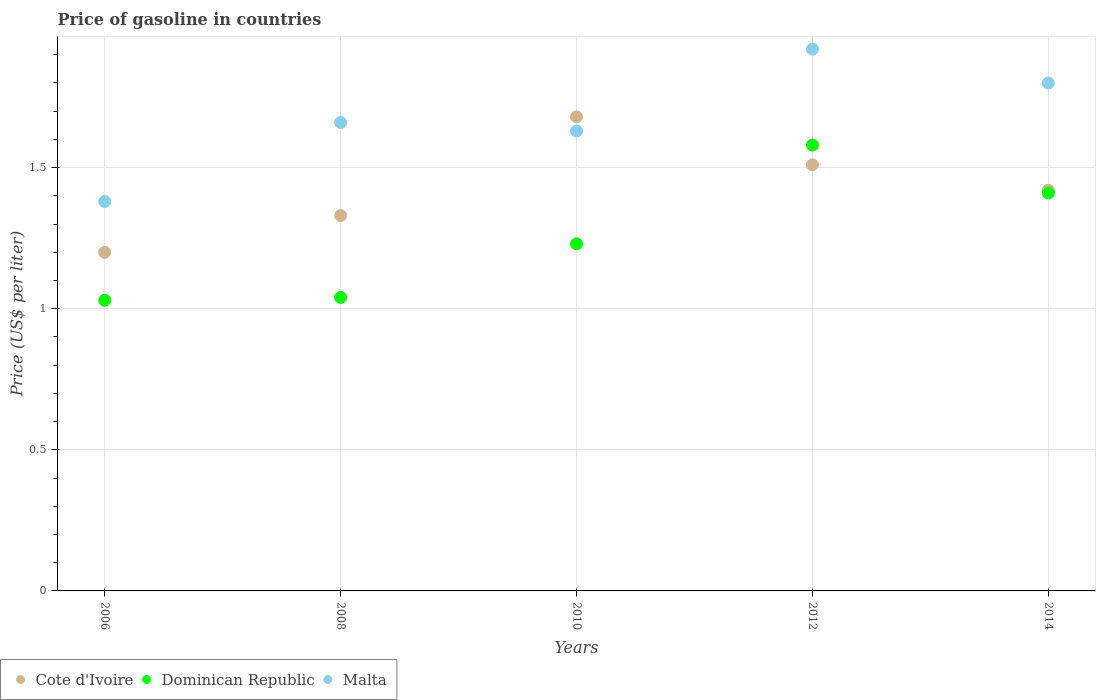Is the number of dotlines equal to the number of legend labels?
Your answer should be compact. Yes. What is the price of gasoline in Cote d'Ivoire in 2012?
Offer a terse response. 1.51. Across all years, what is the maximum price of gasoline in Dominican Republic?
Give a very brief answer. 1.58. Across all years, what is the minimum price of gasoline in Dominican Republic?
Keep it short and to the point. 1.03. In which year was the price of gasoline in Cote d'Ivoire maximum?
Keep it short and to the point. 2010. What is the total price of gasoline in Dominican Republic in the graph?
Ensure brevity in your answer.  6.29. What is the difference between the price of gasoline in Cote d'Ivoire in 2008 and that in 2014?
Ensure brevity in your answer.  -0.09. What is the difference between the price of gasoline in Dominican Republic in 2014 and the price of gasoline in Cote d'Ivoire in 2012?
Provide a succinct answer. -0.1. What is the average price of gasoline in Cote d'Ivoire per year?
Your answer should be compact. 1.43. In the year 2008, what is the difference between the price of gasoline in Cote d'Ivoire and price of gasoline in Dominican Republic?
Ensure brevity in your answer.  0.29. In how many years, is the price of gasoline in Malta greater than 0.8 US$?
Your response must be concise. 5. What is the ratio of the price of gasoline in Malta in 2008 to that in 2012?
Your answer should be compact. 0.86. Is the difference between the price of gasoline in Cote d'Ivoire in 2010 and 2012 greater than the difference between the price of gasoline in Dominican Republic in 2010 and 2012?
Keep it short and to the point. Yes. What is the difference between the highest and the second highest price of gasoline in Cote d'Ivoire?
Offer a terse response. 0.17. What is the difference between the highest and the lowest price of gasoline in Malta?
Your response must be concise. 0.54. Is the sum of the price of gasoline in Dominican Republic in 2008 and 2012 greater than the maximum price of gasoline in Malta across all years?
Give a very brief answer. Yes. Is it the case that in every year, the sum of the price of gasoline in Cote d'Ivoire and price of gasoline in Dominican Republic  is greater than the price of gasoline in Malta?
Your answer should be compact. Yes. Is the price of gasoline in Dominican Republic strictly greater than the price of gasoline in Malta over the years?
Your answer should be compact. No. What is the difference between two consecutive major ticks on the Y-axis?
Provide a short and direct response. 0.5. Are the values on the major ticks of Y-axis written in scientific E-notation?
Provide a short and direct response. No. Does the graph contain any zero values?
Offer a terse response. No. Does the graph contain grids?
Offer a terse response. Yes. Where does the legend appear in the graph?
Ensure brevity in your answer.  Bottom left. How are the legend labels stacked?
Give a very brief answer. Horizontal. What is the title of the graph?
Give a very brief answer. Price of gasoline in countries. What is the label or title of the X-axis?
Keep it short and to the point. Years. What is the label or title of the Y-axis?
Ensure brevity in your answer.  Price (US$ per liter). What is the Price (US$ per liter) in Cote d'Ivoire in 2006?
Your answer should be very brief. 1.2. What is the Price (US$ per liter) in Malta in 2006?
Your response must be concise. 1.38. What is the Price (US$ per liter) of Cote d'Ivoire in 2008?
Ensure brevity in your answer.  1.33. What is the Price (US$ per liter) of Dominican Republic in 2008?
Give a very brief answer. 1.04. What is the Price (US$ per liter) in Malta in 2008?
Your answer should be very brief. 1.66. What is the Price (US$ per liter) in Cote d'Ivoire in 2010?
Your answer should be compact. 1.68. What is the Price (US$ per liter) in Dominican Republic in 2010?
Provide a short and direct response. 1.23. What is the Price (US$ per liter) in Malta in 2010?
Give a very brief answer. 1.63. What is the Price (US$ per liter) of Cote d'Ivoire in 2012?
Your answer should be compact. 1.51. What is the Price (US$ per liter) in Dominican Republic in 2012?
Make the answer very short. 1.58. What is the Price (US$ per liter) of Malta in 2012?
Provide a short and direct response. 1.92. What is the Price (US$ per liter) in Cote d'Ivoire in 2014?
Your answer should be compact. 1.42. What is the Price (US$ per liter) in Dominican Republic in 2014?
Give a very brief answer. 1.41. What is the Price (US$ per liter) in Malta in 2014?
Ensure brevity in your answer.  1.8. Across all years, what is the maximum Price (US$ per liter) of Cote d'Ivoire?
Keep it short and to the point. 1.68. Across all years, what is the maximum Price (US$ per liter) in Dominican Republic?
Your answer should be very brief. 1.58. Across all years, what is the maximum Price (US$ per liter) in Malta?
Keep it short and to the point. 1.92. Across all years, what is the minimum Price (US$ per liter) in Malta?
Give a very brief answer. 1.38. What is the total Price (US$ per liter) in Cote d'Ivoire in the graph?
Ensure brevity in your answer.  7.14. What is the total Price (US$ per liter) of Dominican Republic in the graph?
Offer a terse response. 6.29. What is the total Price (US$ per liter) in Malta in the graph?
Make the answer very short. 8.39. What is the difference between the Price (US$ per liter) in Cote d'Ivoire in 2006 and that in 2008?
Provide a succinct answer. -0.13. What is the difference between the Price (US$ per liter) in Dominican Republic in 2006 and that in 2008?
Your response must be concise. -0.01. What is the difference between the Price (US$ per liter) in Malta in 2006 and that in 2008?
Your response must be concise. -0.28. What is the difference between the Price (US$ per liter) in Cote d'Ivoire in 2006 and that in 2010?
Ensure brevity in your answer.  -0.48. What is the difference between the Price (US$ per liter) of Dominican Republic in 2006 and that in 2010?
Offer a very short reply. -0.2. What is the difference between the Price (US$ per liter) of Cote d'Ivoire in 2006 and that in 2012?
Provide a short and direct response. -0.31. What is the difference between the Price (US$ per liter) of Dominican Republic in 2006 and that in 2012?
Offer a very short reply. -0.55. What is the difference between the Price (US$ per liter) in Malta in 2006 and that in 2012?
Make the answer very short. -0.54. What is the difference between the Price (US$ per liter) in Cote d'Ivoire in 2006 and that in 2014?
Offer a very short reply. -0.22. What is the difference between the Price (US$ per liter) of Dominican Republic in 2006 and that in 2014?
Your answer should be very brief. -0.38. What is the difference between the Price (US$ per liter) of Malta in 2006 and that in 2014?
Provide a short and direct response. -0.42. What is the difference between the Price (US$ per liter) of Cote d'Ivoire in 2008 and that in 2010?
Your response must be concise. -0.35. What is the difference between the Price (US$ per liter) of Dominican Republic in 2008 and that in 2010?
Offer a terse response. -0.19. What is the difference between the Price (US$ per liter) of Cote d'Ivoire in 2008 and that in 2012?
Keep it short and to the point. -0.18. What is the difference between the Price (US$ per liter) of Dominican Republic in 2008 and that in 2012?
Provide a short and direct response. -0.54. What is the difference between the Price (US$ per liter) of Malta in 2008 and that in 2012?
Offer a terse response. -0.26. What is the difference between the Price (US$ per liter) of Cote d'Ivoire in 2008 and that in 2014?
Provide a succinct answer. -0.09. What is the difference between the Price (US$ per liter) in Dominican Republic in 2008 and that in 2014?
Make the answer very short. -0.37. What is the difference between the Price (US$ per liter) in Malta in 2008 and that in 2014?
Give a very brief answer. -0.14. What is the difference between the Price (US$ per liter) in Cote d'Ivoire in 2010 and that in 2012?
Make the answer very short. 0.17. What is the difference between the Price (US$ per liter) in Dominican Republic in 2010 and that in 2012?
Give a very brief answer. -0.35. What is the difference between the Price (US$ per liter) of Malta in 2010 and that in 2012?
Keep it short and to the point. -0.29. What is the difference between the Price (US$ per liter) in Cote d'Ivoire in 2010 and that in 2014?
Provide a short and direct response. 0.26. What is the difference between the Price (US$ per liter) of Dominican Republic in 2010 and that in 2014?
Give a very brief answer. -0.18. What is the difference between the Price (US$ per liter) of Malta in 2010 and that in 2014?
Keep it short and to the point. -0.17. What is the difference between the Price (US$ per liter) in Cote d'Ivoire in 2012 and that in 2014?
Offer a very short reply. 0.09. What is the difference between the Price (US$ per liter) of Dominican Republic in 2012 and that in 2014?
Offer a terse response. 0.17. What is the difference between the Price (US$ per liter) in Malta in 2012 and that in 2014?
Keep it short and to the point. 0.12. What is the difference between the Price (US$ per liter) of Cote d'Ivoire in 2006 and the Price (US$ per liter) of Dominican Republic in 2008?
Your answer should be very brief. 0.16. What is the difference between the Price (US$ per liter) in Cote d'Ivoire in 2006 and the Price (US$ per liter) in Malta in 2008?
Your response must be concise. -0.46. What is the difference between the Price (US$ per liter) of Dominican Republic in 2006 and the Price (US$ per liter) of Malta in 2008?
Ensure brevity in your answer.  -0.63. What is the difference between the Price (US$ per liter) in Cote d'Ivoire in 2006 and the Price (US$ per liter) in Dominican Republic in 2010?
Offer a terse response. -0.03. What is the difference between the Price (US$ per liter) in Cote d'Ivoire in 2006 and the Price (US$ per liter) in Malta in 2010?
Offer a terse response. -0.43. What is the difference between the Price (US$ per liter) of Dominican Republic in 2006 and the Price (US$ per liter) of Malta in 2010?
Your answer should be very brief. -0.6. What is the difference between the Price (US$ per liter) of Cote d'Ivoire in 2006 and the Price (US$ per liter) of Dominican Republic in 2012?
Provide a succinct answer. -0.38. What is the difference between the Price (US$ per liter) in Cote d'Ivoire in 2006 and the Price (US$ per liter) in Malta in 2012?
Keep it short and to the point. -0.72. What is the difference between the Price (US$ per liter) of Dominican Republic in 2006 and the Price (US$ per liter) of Malta in 2012?
Offer a terse response. -0.89. What is the difference between the Price (US$ per liter) in Cote d'Ivoire in 2006 and the Price (US$ per liter) in Dominican Republic in 2014?
Offer a very short reply. -0.21. What is the difference between the Price (US$ per liter) of Cote d'Ivoire in 2006 and the Price (US$ per liter) of Malta in 2014?
Your answer should be very brief. -0.6. What is the difference between the Price (US$ per liter) in Dominican Republic in 2006 and the Price (US$ per liter) in Malta in 2014?
Ensure brevity in your answer.  -0.77. What is the difference between the Price (US$ per liter) in Cote d'Ivoire in 2008 and the Price (US$ per liter) in Dominican Republic in 2010?
Offer a terse response. 0.1. What is the difference between the Price (US$ per liter) of Cote d'Ivoire in 2008 and the Price (US$ per liter) of Malta in 2010?
Your answer should be compact. -0.3. What is the difference between the Price (US$ per liter) of Dominican Republic in 2008 and the Price (US$ per liter) of Malta in 2010?
Ensure brevity in your answer.  -0.59. What is the difference between the Price (US$ per liter) of Cote d'Ivoire in 2008 and the Price (US$ per liter) of Malta in 2012?
Provide a short and direct response. -0.59. What is the difference between the Price (US$ per liter) of Dominican Republic in 2008 and the Price (US$ per liter) of Malta in 2012?
Your answer should be compact. -0.88. What is the difference between the Price (US$ per liter) of Cote d'Ivoire in 2008 and the Price (US$ per liter) of Dominican Republic in 2014?
Provide a succinct answer. -0.08. What is the difference between the Price (US$ per liter) in Cote d'Ivoire in 2008 and the Price (US$ per liter) in Malta in 2014?
Offer a terse response. -0.47. What is the difference between the Price (US$ per liter) in Dominican Republic in 2008 and the Price (US$ per liter) in Malta in 2014?
Your answer should be very brief. -0.76. What is the difference between the Price (US$ per liter) of Cote d'Ivoire in 2010 and the Price (US$ per liter) of Malta in 2012?
Your response must be concise. -0.24. What is the difference between the Price (US$ per liter) of Dominican Republic in 2010 and the Price (US$ per liter) of Malta in 2012?
Provide a short and direct response. -0.69. What is the difference between the Price (US$ per liter) in Cote d'Ivoire in 2010 and the Price (US$ per liter) in Dominican Republic in 2014?
Make the answer very short. 0.27. What is the difference between the Price (US$ per liter) of Cote d'Ivoire in 2010 and the Price (US$ per liter) of Malta in 2014?
Give a very brief answer. -0.12. What is the difference between the Price (US$ per liter) of Dominican Republic in 2010 and the Price (US$ per liter) of Malta in 2014?
Offer a terse response. -0.57. What is the difference between the Price (US$ per liter) in Cote d'Ivoire in 2012 and the Price (US$ per liter) in Dominican Republic in 2014?
Your answer should be compact. 0.1. What is the difference between the Price (US$ per liter) in Cote d'Ivoire in 2012 and the Price (US$ per liter) in Malta in 2014?
Your response must be concise. -0.29. What is the difference between the Price (US$ per liter) of Dominican Republic in 2012 and the Price (US$ per liter) of Malta in 2014?
Ensure brevity in your answer.  -0.22. What is the average Price (US$ per liter) in Cote d'Ivoire per year?
Offer a very short reply. 1.43. What is the average Price (US$ per liter) of Dominican Republic per year?
Your answer should be compact. 1.26. What is the average Price (US$ per liter) of Malta per year?
Your answer should be very brief. 1.68. In the year 2006, what is the difference between the Price (US$ per liter) of Cote d'Ivoire and Price (US$ per liter) of Dominican Republic?
Your response must be concise. 0.17. In the year 2006, what is the difference between the Price (US$ per liter) in Cote d'Ivoire and Price (US$ per liter) in Malta?
Provide a short and direct response. -0.18. In the year 2006, what is the difference between the Price (US$ per liter) in Dominican Republic and Price (US$ per liter) in Malta?
Your answer should be very brief. -0.35. In the year 2008, what is the difference between the Price (US$ per liter) of Cote d'Ivoire and Price (US$ per liter) of Dominican Republic?
Offer a very short reply. 0.29. In the year 2008, what is the difference between the Price (US$ per liter) in Cote d'Ivoire and Price (US$ per liter) in Malta?
Provide a short and direct response. -0.33. In the year 2008, what is the difference between the Price (US$ per liter) of Dominican Republic and Price (US$ per liter) of Malta?
Your answer should be compact. -0.62. In the year 2010, what is the difference between the Price (US$ per liter) in Cote d'Ivoire and Price (US$ per liter) in Dominican Republic?
Offer a terse response. 0.45. In the year 2010, what is the difference between the Price (US$ per liter) in Dominican Republic and Price (US$ per liter) in Malta?
Provide a short and direct response. -0.4. In the year 2012, what is the difference between the Price (US$ per liter) of Cote d'Ivoire and Price (US$ per liter) of Dominican Republic?
Offer a terse response. -0.07. In the year 2012, what is the difference between the Price (US$ per liter) of Cote d'Ivoire and Price (US$ per liter) of Malta?
Offer a very short reply. -0.41. In the year 2012, what is the difference between the Price (US$ per liter) of Dominican Republic and Price (US$ per liter) of Malta?
Make the answer very short. -0.34. In the year 2014, what is the difference between the Price (US$ per liter) of Cote d'Ivoire and Price (US$ per liter) of Dominican Republic?
Give a very brief answer. 0.01. In the year 2014, what is the difference between the Price (US$ per liter) in Cote d'Ivoire and Price (US$ per liter) in Malta?
Make the answer very short. -0.38. In the year 2014, what is the difference between the Price (US$ per liter) of Dominican Republic and Price (US$ per liter) of Malta?
Make the answer very short. -0.39. What is the ratio of the Price (US$ per liter) of Cote d'Ivoire in 2006 to that in 2008?
Offer a very short reply. 0.9. What is the ratio of the Price (US$ per liter) of Malta in 2006 to that in 2008?
Give a very brief answer. 0.83. What is the ratio of the Price (US$ per liter) in Cote d'Ivoire in 2006 to that in 2010?
Your answer should be compact. 0.71. What is the ratio of the Price (US$ per liter) of Dominican Republic in 2006 to that in 2010?
Make the answer very short. 0.84. What is the ratio of the Price (US$ per liter) of Malta in 2006 to that in 2010?
Ensure brevity in your answer.  0.85. What is the ratio of the Price (US$ per liter) in Cote d'Ivoire in 2006 to that in 2012?
Provide a short and direct response. 0.79. What is the ratio of the Price (US$ per liter) in Dominican Republic in 2006 to that in 2012?
Offer a terse response. 0.65. What is the ratio of the Price (US$ per liter) of Malta in 2006 to that in 2012?
Offer a terse response. 0.72. What is the ratio of the Price (US$ per liter) of Cote d'Ivoire in 2006 to that in 2014?
Provide a succinct answer. 0.85. What is the ratio of the Price (US$ per liter) in Dominican Republic in 2006 to that in 2014?
Your answer should be compact. 0.73. What is the ratio of the Price (US$ per liter) of Malta in 2006 to that in 2014?
Your answer should be very brief. 0.77. What is the ratio of the Price (US$ per liter) of Cote d'Ivoire in 2008 to that in 2010?
Your answer should be compact. 0.79. What is the ratio of the Price (US$ per liter) in Dominican Republic in 2008 to that in 2010?
Offer a very short reply. 0.85. What is the ratio of the Price (US$ per liter) of Malta in 2008 to that in 2010?
Ensure brevity in your answer.  1.02. What is the ratio of the Price (US$ per liter) of Cote d'Ivoire in 2008 to that in 2012?
Your response must be concise. 0.88. What is the ratio of the Price (US$ per liter) in Dominican Republic in 2008 to that in 2012?
Provide a succinct answer. 0.66. What is the ratio of the Price (US$ per liter) of Malta in 2008 to that in 2012?
Provide a succinct answer. 0.86. What is the ratio of the Price (US$ per liter) in Cote d'Ivoire in 2008 to that in 2014?
Offer a terse response. 0.94. What is the ratio of the Price (US$ per liter) in Dominican Republic in 2008 to that in 2014?
Offer a very short reply. 0.74. What is the ratio of the Price (US$ per liter) in Malta in 2008 to that in 2014?
Ensure brevity in your answer.  0.92. What is the ratio of the Price (US$ per liter) of Cote d'Ivoire in 2010 to that in 2012?
Your response must be concise. 1.11. What is the ratio of the Price (US$ per liter) of Dominican Republic in 2010 to that in 2012?
Ensure brevity in your answer.  0.78. What is the ratio of the Price (US$ per liter) of Malta in 2010 to that in 2012?
Your answer should be compact. 0.85. What is the ratio of the Price (US$ per liter) of Cote d'Ivoire in 2010 to that in 2014?
Your response must be concise. 1.18. What is the ratio of the Price (US$ per liter) in Dominican Republic in 2010 to that in 2014?
Offer a terse response. 0.87. What is the ratio of the Price (US$ per liter) of Malta in 2010 to that in 2014?
Make the answer very short. 0.91. What is the ratio of the Price (US$ per liter) of Cote d'Ivoire in 2012 to that in 2014?
Offer a very short reply. 1.06. What is the ratio of the Price (US$ per liter) of Dominican Republic in 2012 to that in 2014?
Make the answer very short. 1.12. What is the ratio of the Price (US$ per liter) of Malta in 2012 to that in 2014?
Make the answer very short. 1.07. What is the difference between the highest and the second highest Price (US$ per liter) of Cote d'Ivoire?
Provide a succinct answer. 0.17. What is the difference between the highest and the second highest Price (US$ per liter) in Dominican Republic?
Offer a very short reply. 0.17. What is the difference between the highest and the second highest Price (US$ per liter) of Malta?
Offer a very short reply. 0.12. What is the difference between the highest and the lowest Price (US$ per liter) in Cote d'Ivoire?
Make the answer very short. 0.48. What is the difference between the highest and the lowest Price (US$ per liter) of Dominican Republic?
Your response must be concise. 0.55. What is the difference between the highest and the lowest Price (US$ per liter) in Malta?
Your response must be concise. 0.54. 